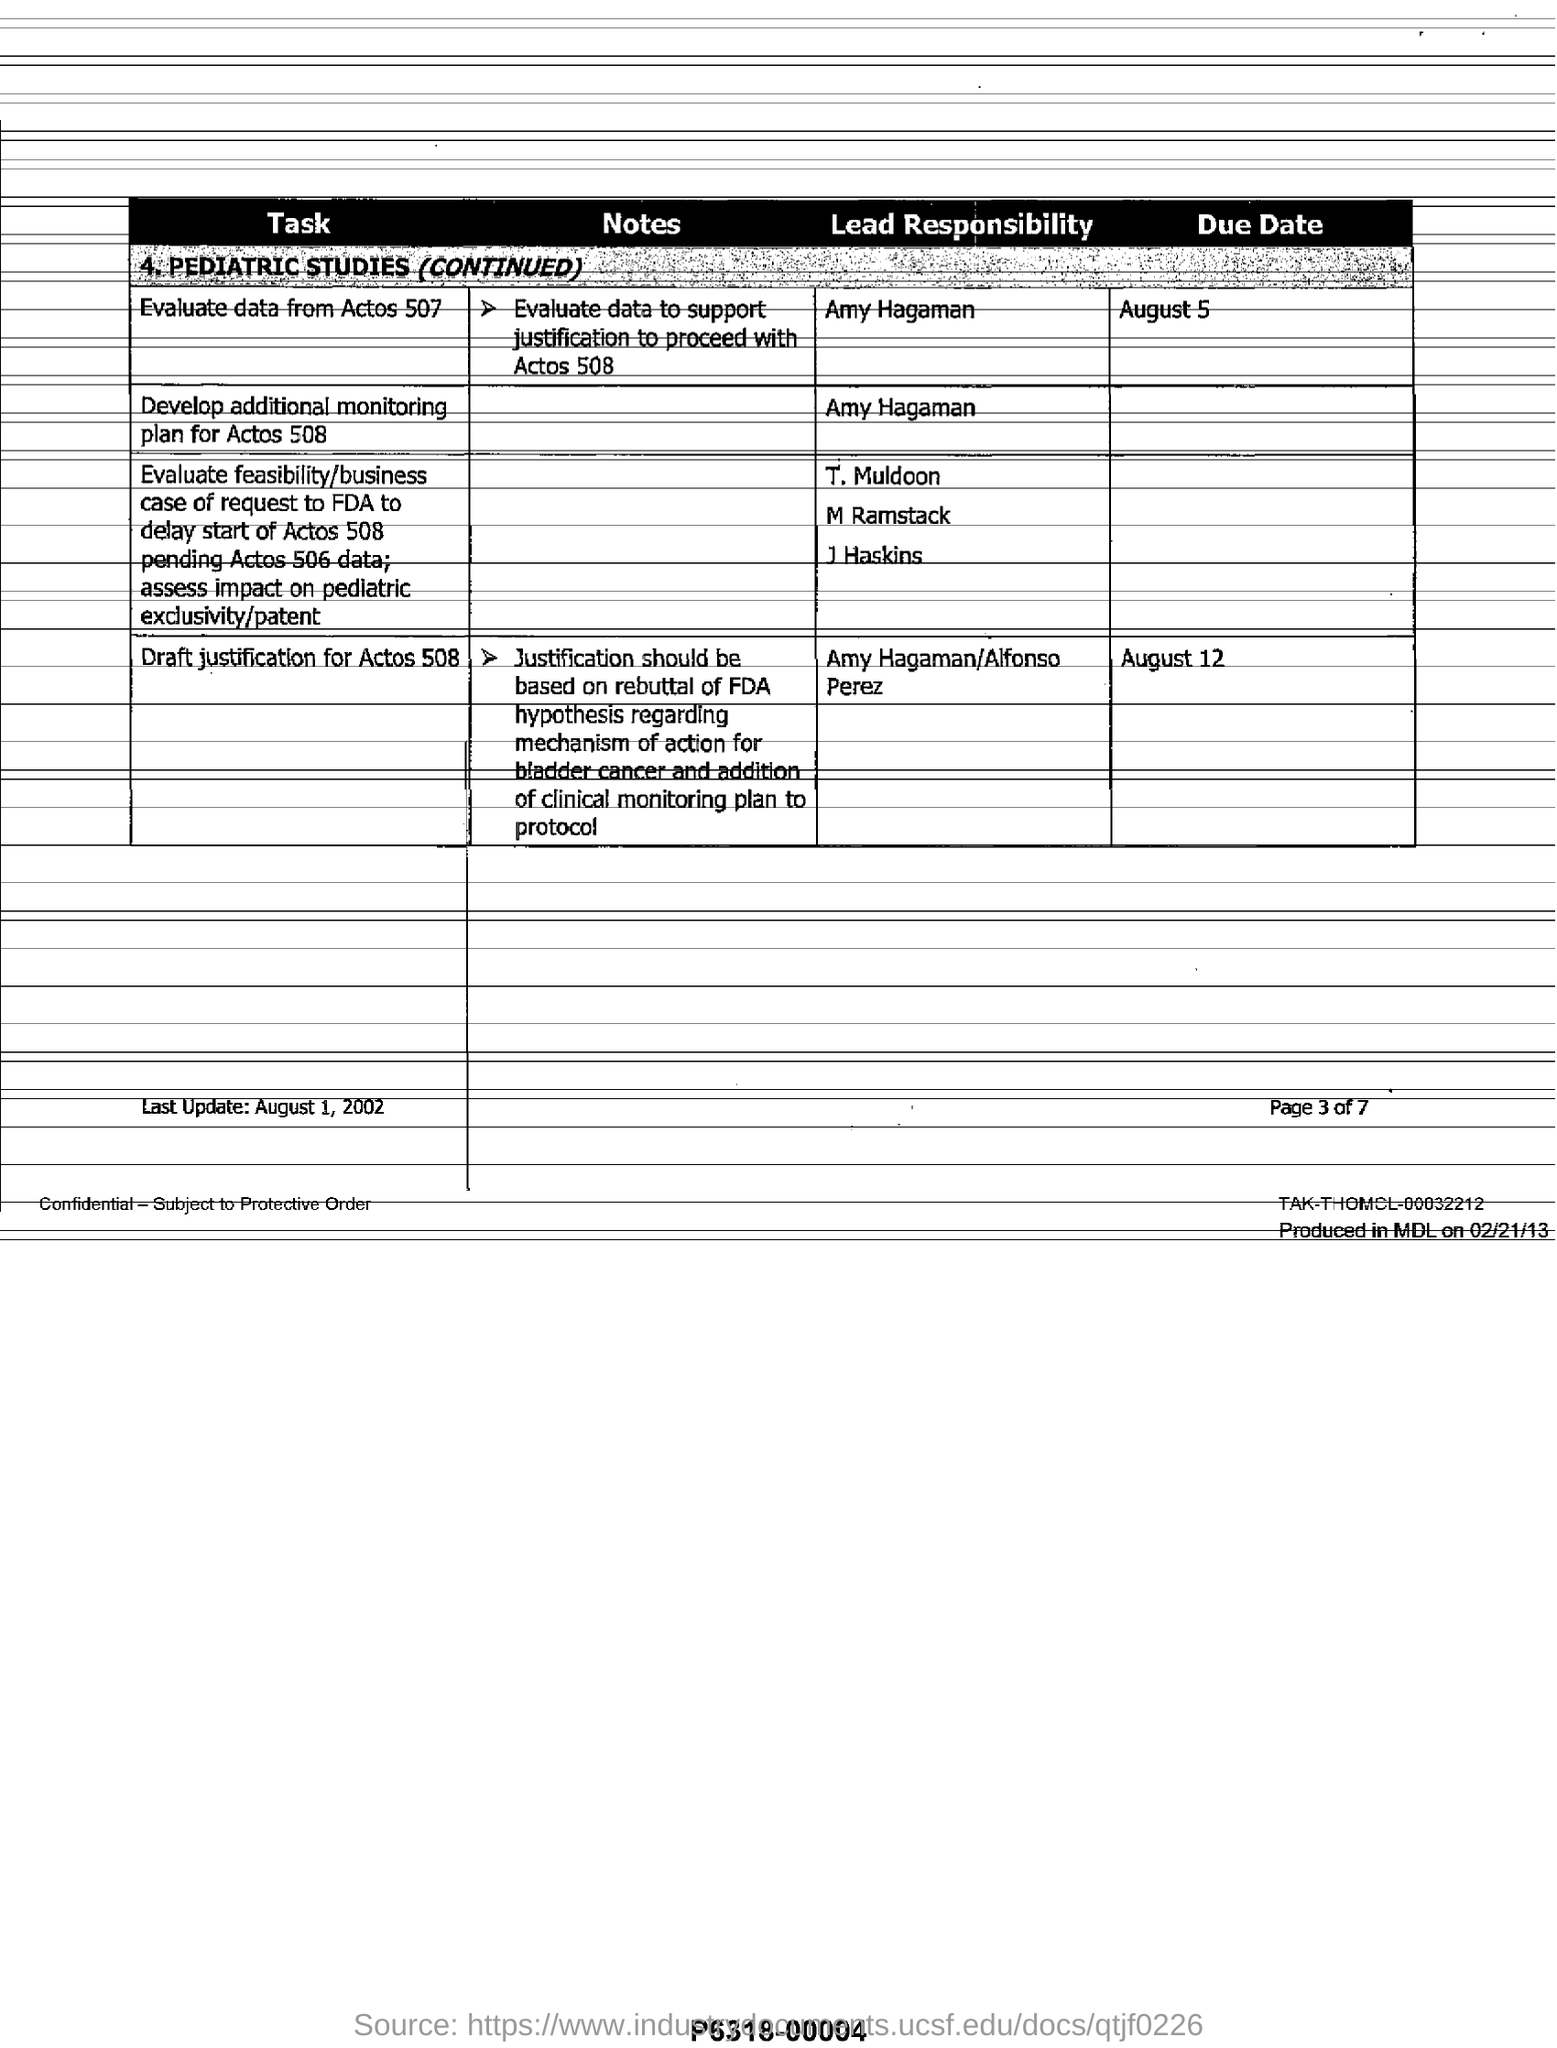Indicate a few pertinent items in this graphic. It is Amy Hagaman's responsibility to develop the additional monitoring plan for Actos 508. There are a total of 7 pages in this document. The due date for the draft justification for Actos 508 is August 12. The due date to evaluate data from Actos 507 is August 5. This was last updated on August 1, 2002. 